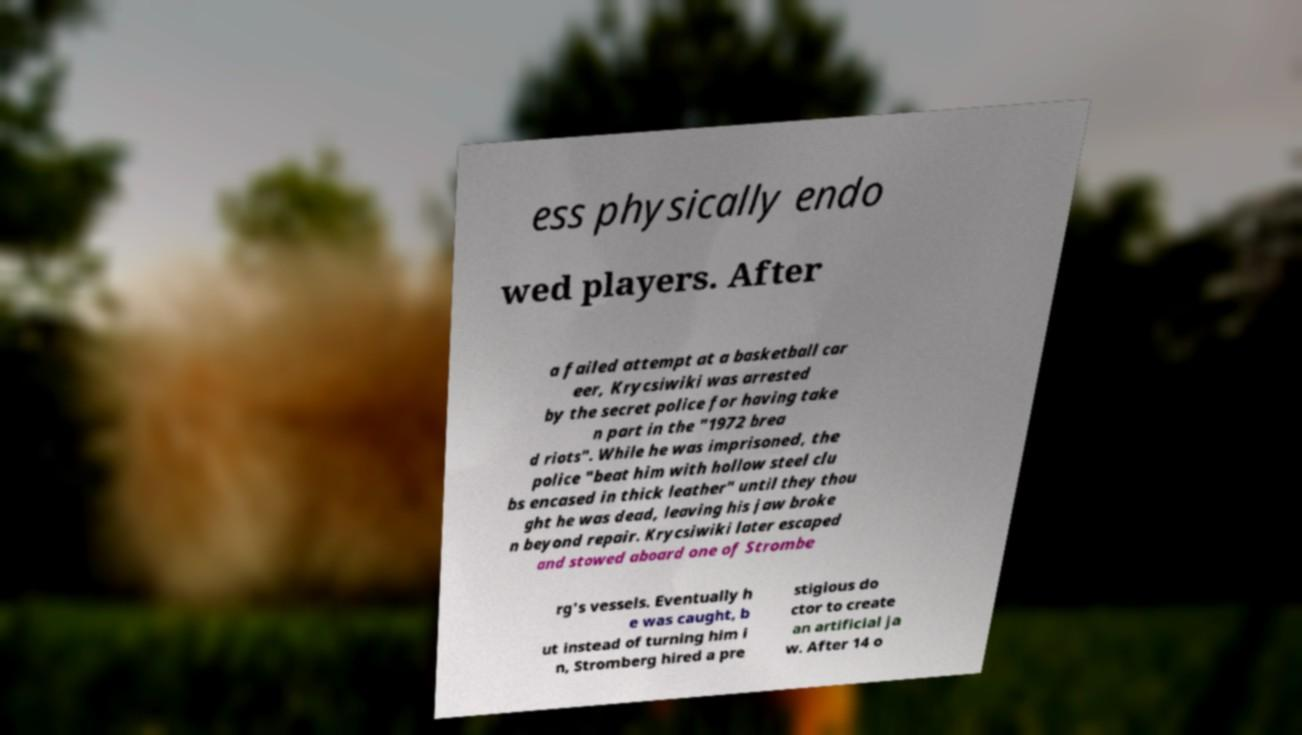For documentation purposes, I need the text within this image transcribed. Could you provide that? ess physically endo wed players. After a failed attempt at a basketball car eer, Krycsiwiki was arrested by the secret police for having take n part in the "1972 brea d riots". While he was imprisoned, the police "beat him with hollow steel clu bs encased in thick leather" until they thou ght he was dead, leaving his jaw broke n beyond repair. Krycsiwiki later escaped and stowed aboard one of Strombe rg's vessels. Eventually h e was caught, b ut instead of turning him i n, Stromberg hired a pre stigious do ctor to create an artificial ja w. After 14 o 